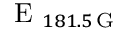<formula> <loc_0><loc_0><loc_500><loc_500>E _ { 1 8 1 . 5 \, G }</formula> 